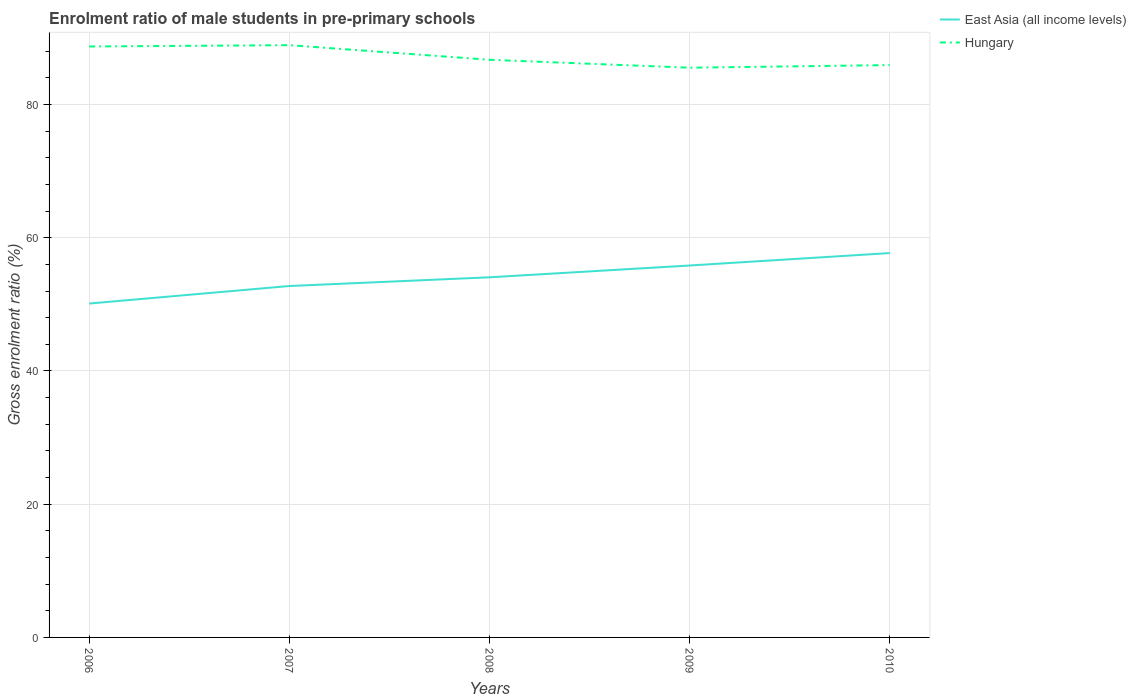How many different coloured lines are there?
Make the answer very short. 2. Is the number of lines equal to the number of legend labels?
Your answer should be compact. Yes. Across all years, what is the maximum enrolment ratio of male students in pre-primary schools in East Asia (all income levels)?
Offer a terse response. 50.12. What is the total enrolment ratio of male students in pre-primary schools in East Asia (all income levels) in the graph?
Give a very brief answer. -3.64. What is the difference between the highest and the second highest enrolment ratio of male students in pre-primary schools in East Asia (all income levels)?
Provide a short and direct response. 7.58. What is the difference between the highest and the lowest enrolment ratio of male students in pre-primary schools in East Asia (all income levels)?
Make the answer very short. 2. Is the enrolment ratio of male students in pre-primary schools in East Asia (all income levels) strictly greater than the enrolment ratio of male students in pre-primary schools in Hungary over the years?
Your answer should be compact. Yes. How many lines are there?
Offer a terse response. 2. How many years are there in the graph?
Your response must be concise. 5. What is the difference between two consecutive major ticks on the Y-axis?
Your answer should be very brief. 20. Are the values on the major ticks of Y-axis written in scientific E-notation?
Offer a terse response. No. Does the graph contain grids?
Keep it short and to the point. Yes. Where does the legend appear in the graph?
Provide a short and direct response. Top right. How many legend labels are there?
Keep it short and to the point. 2. What is the title of the graph?
Give a very brief answer. Enrolment ratio of male students in pre-primary schools. Does "Bosnia and Herzegovina" appear as one of the legend labels in the graph?
Your answer should be very brief. No. What is the label or title of the X-axis?
Give a very brief answer. Years. What is the Gross enrolment ratio (%) of East Asia (all income levels) in 2006?
Offer a very short reply. 50.12. What is the Gross enrolment ratio (%) in Hungary in 2006?
Provide a short and direct response. 88.7. What is the Gross enrolment ratio (%) of East Asia (all income levels) in 2007?
Give a very brief answer. 52.75. What is the Gross enrolment ratio (%) of Hungary in 2007?
Ensure brevity in your answer.  88.9. What is the Gross enrolment ratio (%) in East Asia (all income levels) in 2008?
Keep it short and to the point. 54.06. What is the Gross enrolment ratio (%) of Hungary in 2008?
Keep it short and to the point. 86.71. What is the Gross enrolment ratio (%) of East Asia (all income levels) in 2009?
Offer a very short reply. 55.83. What is the Gross enrolment ratio (%) in Hungary in 2009?
Offer a terse response. 85.52. What is the Gross enrolment ratio (%) in East Asia (all income levels) in 2010?
Offer a terse response. 57.7. What is the Gross enrolment ratio (%) in Hungary in 2010?
Provide a succinct answer. 85.91. Across all years, what is the maximum Gross enrolment ratio (%) in East Asia (all income levels)?
Provide a succinct answer. 57.7. Across all years, what is the maximum Gross enrolment ratio (%) of Hungary?
Ensure brevity in your answer.  88.9. Across all years, what is the minimum Gross enrolment ratio (%) in East Asia (all income levels)?
Ensure brevity in your answer.  50.12. Across all years, what is the minimum Gross enrolment ratio (%) of Hungary?
Provide a succinct answer. 85.52. What is the total Gross enrolment ratio (%) of East Asia (all income levels) in the graph?
Keep it short and to the point. 270.45. What is the total Gross enrolment ratio (%) of Hungary in the graph?
Ensure brevity in your answer.  435.75. What is the difference between the Gross enrolment ratio (%) of East Asia (all income levels) in 2006 and that in 2007?
Ensure brevity in your answer.  -2.63. What is the difference between the Gross enrolment ratio (%) of Hungary in 2006 and that in 2007?
Make the answer very short. -0.2. What is the difference between the Gross enrolment ratio (%) of East Asia (all income levels) in 2006 and that in 2008?
Provide a succinct answer. -3.94. What is the difference between the Gross enrolment ratio (%) of Hungary in 2006 and that in 2008?
Keep it short and to the point. 2. What is the difference between the Gross enrolment ratio (%) of East Asia (all income levels) in 2006 and that in 2009?
Provide a short and direct response. -5.71. What is the difference between the Gross enrolment ratio (%) in Hungary in 2006 and that in 2009?
Your answer should be compact. 3.18. What is the difference between the Gross enrolment ratio (%) of East Asia (all income levels) in 2006 and that in 2010?
Keep it short and to the point. -7.58. What is the difference between the Gross enrolment ratio (%) in Hungary in 2006 and that in 2010?
Give a very brief answer. 2.79. What is the difference between the Gross enrolment ratio (%) of East Asia (all income levels) in 2007 and that in 2008?
Offer a very short reply. -1.31. What is the difference between the Gross enrolment ratio (%) of Hungary in 2007 and that in 2008?
Provide a succinct answer. 2.19. What is the difference between the Gross enrolment ratio (%) in East Asia (all income levels) in 2007 and that in 2009?
Ensure brevity in your answer.  -3.08. What is the difference between the Gross enrolment ratio (%) in Hungary in 2007 and that in 2009?
Your answer should be very brief. 3.38. What is the difference between the Gross enrolment ratio (%) of East Asia (all income levels) in 2007 and that in 2010?
Keep it short and to the point. -4.94. What is the difference between the Gross enrolment ratio (%) of Hungary in 2007 and that in 2010?
Keep it short and to the point. 2.99. What is the difference between the Gross enrolment ratio (%) of East Asia (all income levels) in 2008 and that in 2009?
Provide a short and direct response. -1.77. What is the difference between the Gross enrolment ratio (%) in Hungary in 2008 and that in 2009?
Make the answer very short. 1.19. What is the difference between the Gross enrolment ratio (%) of East Asia (all income levels) in 2008 and that in 2010?
Offer a terse response. -3.64. What is the difference between the Gross enrolment ratio (%) of Hungary in 2008 and that in 2010?
Offer a terse response. 0.8. What is the difference between the Gross enrolment ratio (%) of East Asia (all income levels) in 2009 and that in 2010?
Ensure brevity in your answer.  -1.87. What is the difference between the Gross enrolment ratio (%) of Hungary in 2009 and that in 2010?
Offer a very short reply. -0.39. What is the difference between the Gross enrolment ratio (%) of East Asia (all income levels) in 2006 and the Gross enrolment ratio (%) of Hungary in 2007?
Offer a terse response. -38.78. What is the difference between the Gross enrolment ratio (%) of East Asia (all income levels) in 2006 and the Gross enrolment ratio (%) of Hungary in 2008?
Offer a very short reply. -36.59. What is the difference between the Gross enrolment ratio (%) of East Asia (all income levels) in 2006 and the Gross enrolment ratio (%) of Hungary in 2009?
Your response must be concise. -35.4. What is the difference between the Gross enrolment ratio (%) in East Asia (all income levels) in 2006 and the Gross enrolment ratio (%) in Hungary in 2010?
Ensure brevity in your answer.  -35.79. What is the difference between the Gross enrolment ratio (%) of East Asia (all income levels) in 2007 and the Gross enrolment ratio (%) of Hungary in 2008?
Your answer should be compact. -33.96. What is the difference between the Gross enrolment ratio (%) of East Asia (all income levels) in 2007 and the Gross enrolment ratio (%) of Hungary in 2009?
Provide a short and direct response. -32.77. What is the difference between the Gross enrolment ratio (%) in East Asia (all income levels) in 2007 and the Gross enrolment ratio (%) in Hungary in 2010?
Make the answer very short. -33.16. What is the difference between the Gross enrolment ratio (%) of East Asia (all income levels) in 2008 and the Gross enrolment ratio (%) of Hungary in 2009?
Provide a succinct answer. -31.46. What is the difference between the Gross enrolment ratio (%) of East Asia (all income levels) in 2008 and the Gross enrolment ratio (%) of Hungary in 2010?
Make the answer very short. -31.86. What is the difference between the Gross enrolment ratio (%) of East Asia (all income levels) in 2009 and the Gross enrolment ratio (%) of Hungary in 2010?
Make the answer very short. -30.08. What is the average Gross enrolment ratio (%) of East Asia (all income levels) per year?
Make the answer very short. 54.09. What is the average Gross enrolment ratio (%) in Hungary per year?
Your answer should be very brief. 87.15. In the year 2006, what is the difference between the Gross enrolment ratio (%) of East Asia (all income levels) and Gross enrolment ratio (%) of Hungary?
Your answer should be very brief. -38.59. In the year 2007, what is the difference between the Gross enrolment ratio (%) of East Asia (all income levels) and Gross enrolment ratio (%) of Hungary?
Keep it short and to the point. -36.15. In the year 2008, what is the difference between the Gross enrolment ratio (%) in East Asia (all income levels) and Gross enrolment ratio (%) in Hungary?
Your answer should be very brief. -32.65. In the year 2009, what is the difference between the Gross enrolment ratio (%) in East Asia (all income levels) and Gross enrolment ratio (%) in Hungary?
Give a very brief answer. -29.69. In the year 2010, what is the difference between the Gross enrolment ratio (%) in East Asia (all income levels) and Gross enrolment ratio (%) in Hungary?
Give a very brief answer. -28.22. What is the ratio of the Gross enrolment ratio (%) in East Asia (all income levels) in 2006 to that in 2007?
Offer a very short reply. 0.95. What is the ratio of the Gross enrolment ratio (%) of Hungary in 2006 to that in 2007?
Make the answer very short. 1. What is the ratio of the Gross enrolment ratio (%) of East Asia (all income levels) in 2006 to that in 2008?
Your answer should be compact. 0.93. What is the ratio of the Gross enrolment ratio (%) in Hungary in 2006 to that in 2008?
Provide a short and direct response. 1.02. What is the ratio of the Gross enrolment ratio (%) in East Asia (all income levels) in 2006 to that in 2009?
Offer a terse response. 0.9. What is the ratio of the Gross enrolment ratio (%) in Hungary in 2006 to that in 2009?
Keep it short and to the point. 1.04. What is the ratio of the Gross enrolment ratio (%) of East Asia (all income levels) in 2006 to that in 2010?
Your answer should be compact. 0.87. What is the ratio of the Gross enrolment ratio (%) of Hungary in 2006 to that in 2010?
Your answer should be very brief. 1.03. What is the ratio of the Gross enrolment ratio (%) in East Asia (all income levels) in 2007 to that in 2008?
Give a very brief answer. 0.98. What is the ratio of the Gross enrolment ratio (%) in Hungary in 2007 to that in 2008?
Keep it short and to the point. 1.03. What is the ratio of the Gross enrolment ratio (%) in East Asia (all income levels) in 2007 to that in 2009?
Ensure brevity in your answer.  0.94. What is the ratio of the Gross enrolment ratio (%) in Hungary in 2007 to that in 2009?
Provide a succinct answer. 1.04. What is the ratio of the Gross enrolment ratio (%) of East Asia (all income levels) in 2007 to that in 2010?
Give a very brief answer. 0.91. What is the ratio of the Gross enrolment ratio (%) in Hungary in 2007 to that in 2010?
Provide a succinct answer. 1.03. What is the ratio of the Gross enrolment ratio (%) in East Asia (all income levels) in 2008 to that in 2009?
Offer a very short reply. 0.97. What is the ratio of the Gross enrolment ratio (%) in Hungary in 2008 to that in 2009?
Make the answer very short. 1.01. What is the ratio of the Gross enrolment ratio (%) of East Asia (all income levels) in 2008 to that in 2010?
Ensure brevity in your answer.  0.94. What is the ratio of the Gross enrolment ratio (%) of Hungary in 2008 to that in 2010?
Give a very brief answer. 1.01. What is the ratio of the Gross enrolment ratio (%) in East Asia (all income levels) in 2009 to that in 2010?
Give a very brief answer. 0.97. What is the ratio of the Gross enrolment ratio (%) of Hungary in 2009 to that in 2010?
Provide a short and direct response. 1. What is the difference between the highest and the second highest Gross enrolment ratio (%) in East Asia (all income levels)?
Your answer should be very brief. 1.87. What is the difference between the highest and the second highest Gross enrolment ratio (%) of Hungary?
Make the answer very short. 0.2. What is the difference between the highest and the lowest Gross enrolment ratio (%) of East Asia (all income levels)?
Make the answer very short. 7.58. What is the difference between the highest and the lowest Gross enrolment ratio (%) of Hungary?
Offer a terse response. 3.38. 